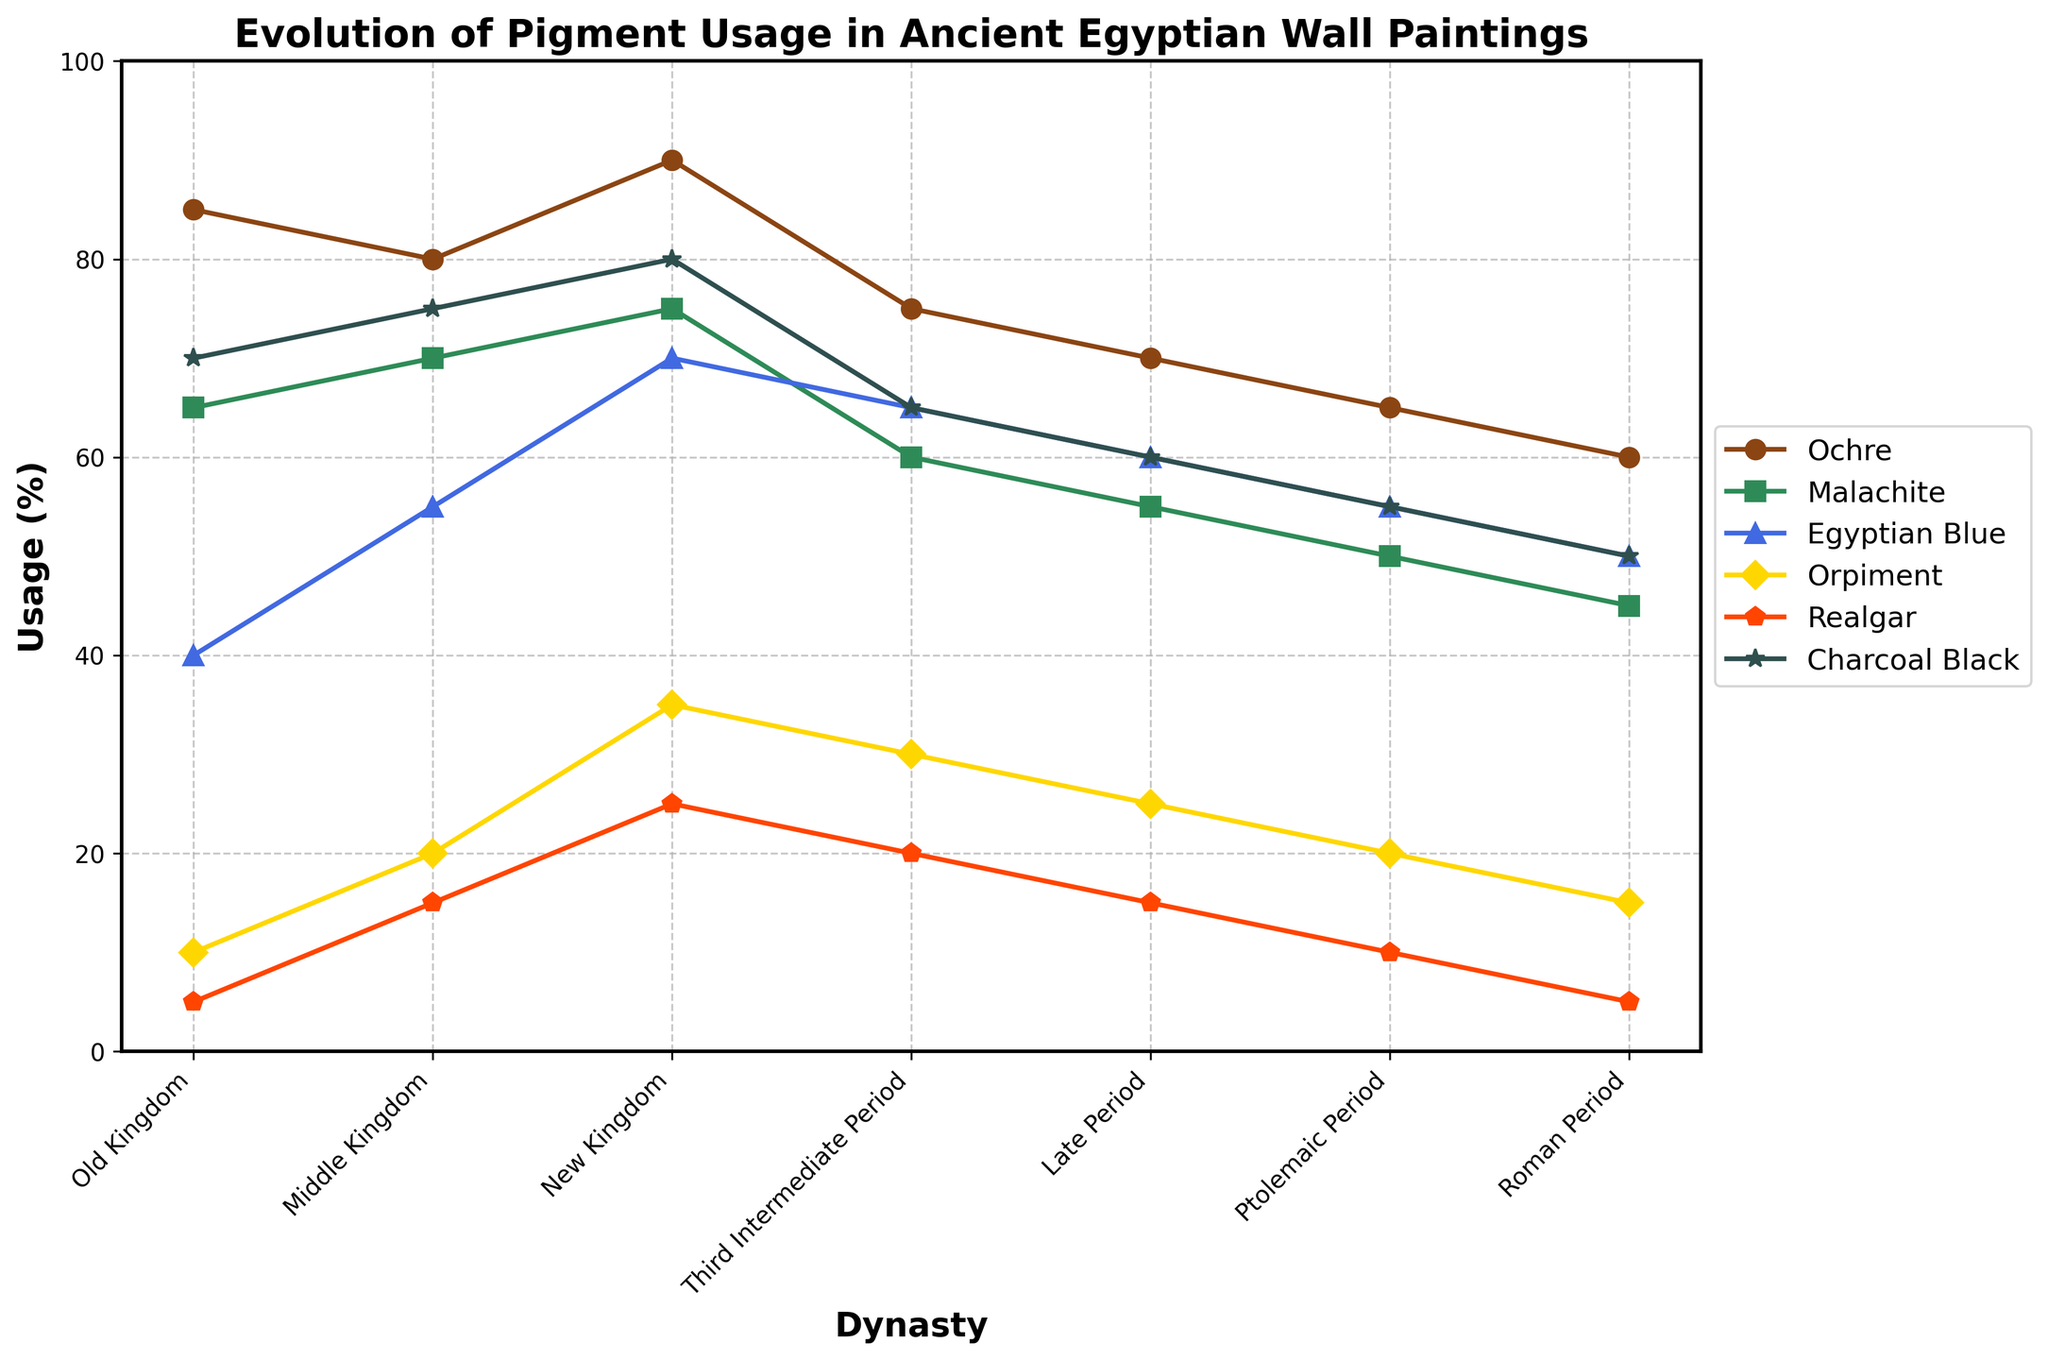When did the usage of Ochre peak, and what percentage was it? Ochre usage peaked during the New Kingdom. To determine this, look for the dynasty label on the x-axis corresponding to the highest Y-value for the Ochre line (typically brown), which is 90%.
Answer: New Kingdom, 90% Which pigment had the lowest usage percentage in the Roman Period? The lowest value in the Roman Period column is Egyptian Blue. Check the y-values corresponding to the Roman Period on the x-axis and identify the lowest point: 50% for Egyptian Blue.
Answer: Egyptian Blue How did the usage of Realgar change from the Old Kingdom to the Middle Kingdom? Subtract the Old Kingdom value of Realgar (5) from the Middle Kingdom value (15), resulting in a 10-point increase.
Answer: Increased by 10% What percentage of Egyptian Blue was used in the Middle Kingdom, and how does this compare to the New Kingdom? Identify the Egyptian Blue points on the Middle Kingdom (55) and New Kingdom (70) lines on the y-axis. Subtract the Middle Kingdom value from the New Kingdom value (70 - 55 = 15), which shows a 15-point increase.
Answer: 55% in the Middle Kingdom, 15% increase to the New Kingdom Which period saw the largest decrease in usage of Malachite compared to its preceding dynasty? Compare the differences between consecutive points of Malachite. The largest drop is from the New Kingdom (75) to the Third Intermediate Period (60), a decrease of 15 points.
Answer: Third Intermediate Period What is the average percentage usage of Charcoal Black over all periods? Sum the Charcoal Black values (70 + 75 + 80 + 65 + 60 + 55 + 50) and divide by the number of periods (7), resulting in an average. (70+75+80+65+60+55+50)/7 = 65.
Answer: 65% How does the usage of Orpiment in the New Kingdom compare to its usage in the Old Kingdom? Identify values for Orpiment in the New Kingdom (35) and the Old Kingdom (10). Subtract the Old Kingdom’s value from the New Kingdom’s (35 - 10 = 25), showing an increase of 25%.
Answer: Increased by 25% Which two pigments had the closest usage percentages in the Late Period? Compare pigment values for the Late Period. Malachite and Egyptian Blue both have 55%, which are the closest.
Answer: Malachite and Egyptian Blue What was the usage trend of Ochre from the Old Kingdom to the Roman Period? Track the Ochre line from Old Kingdom (85) to Roman Period (60). The trend shows a consistent decrease.
Answer: Decreasing trend 